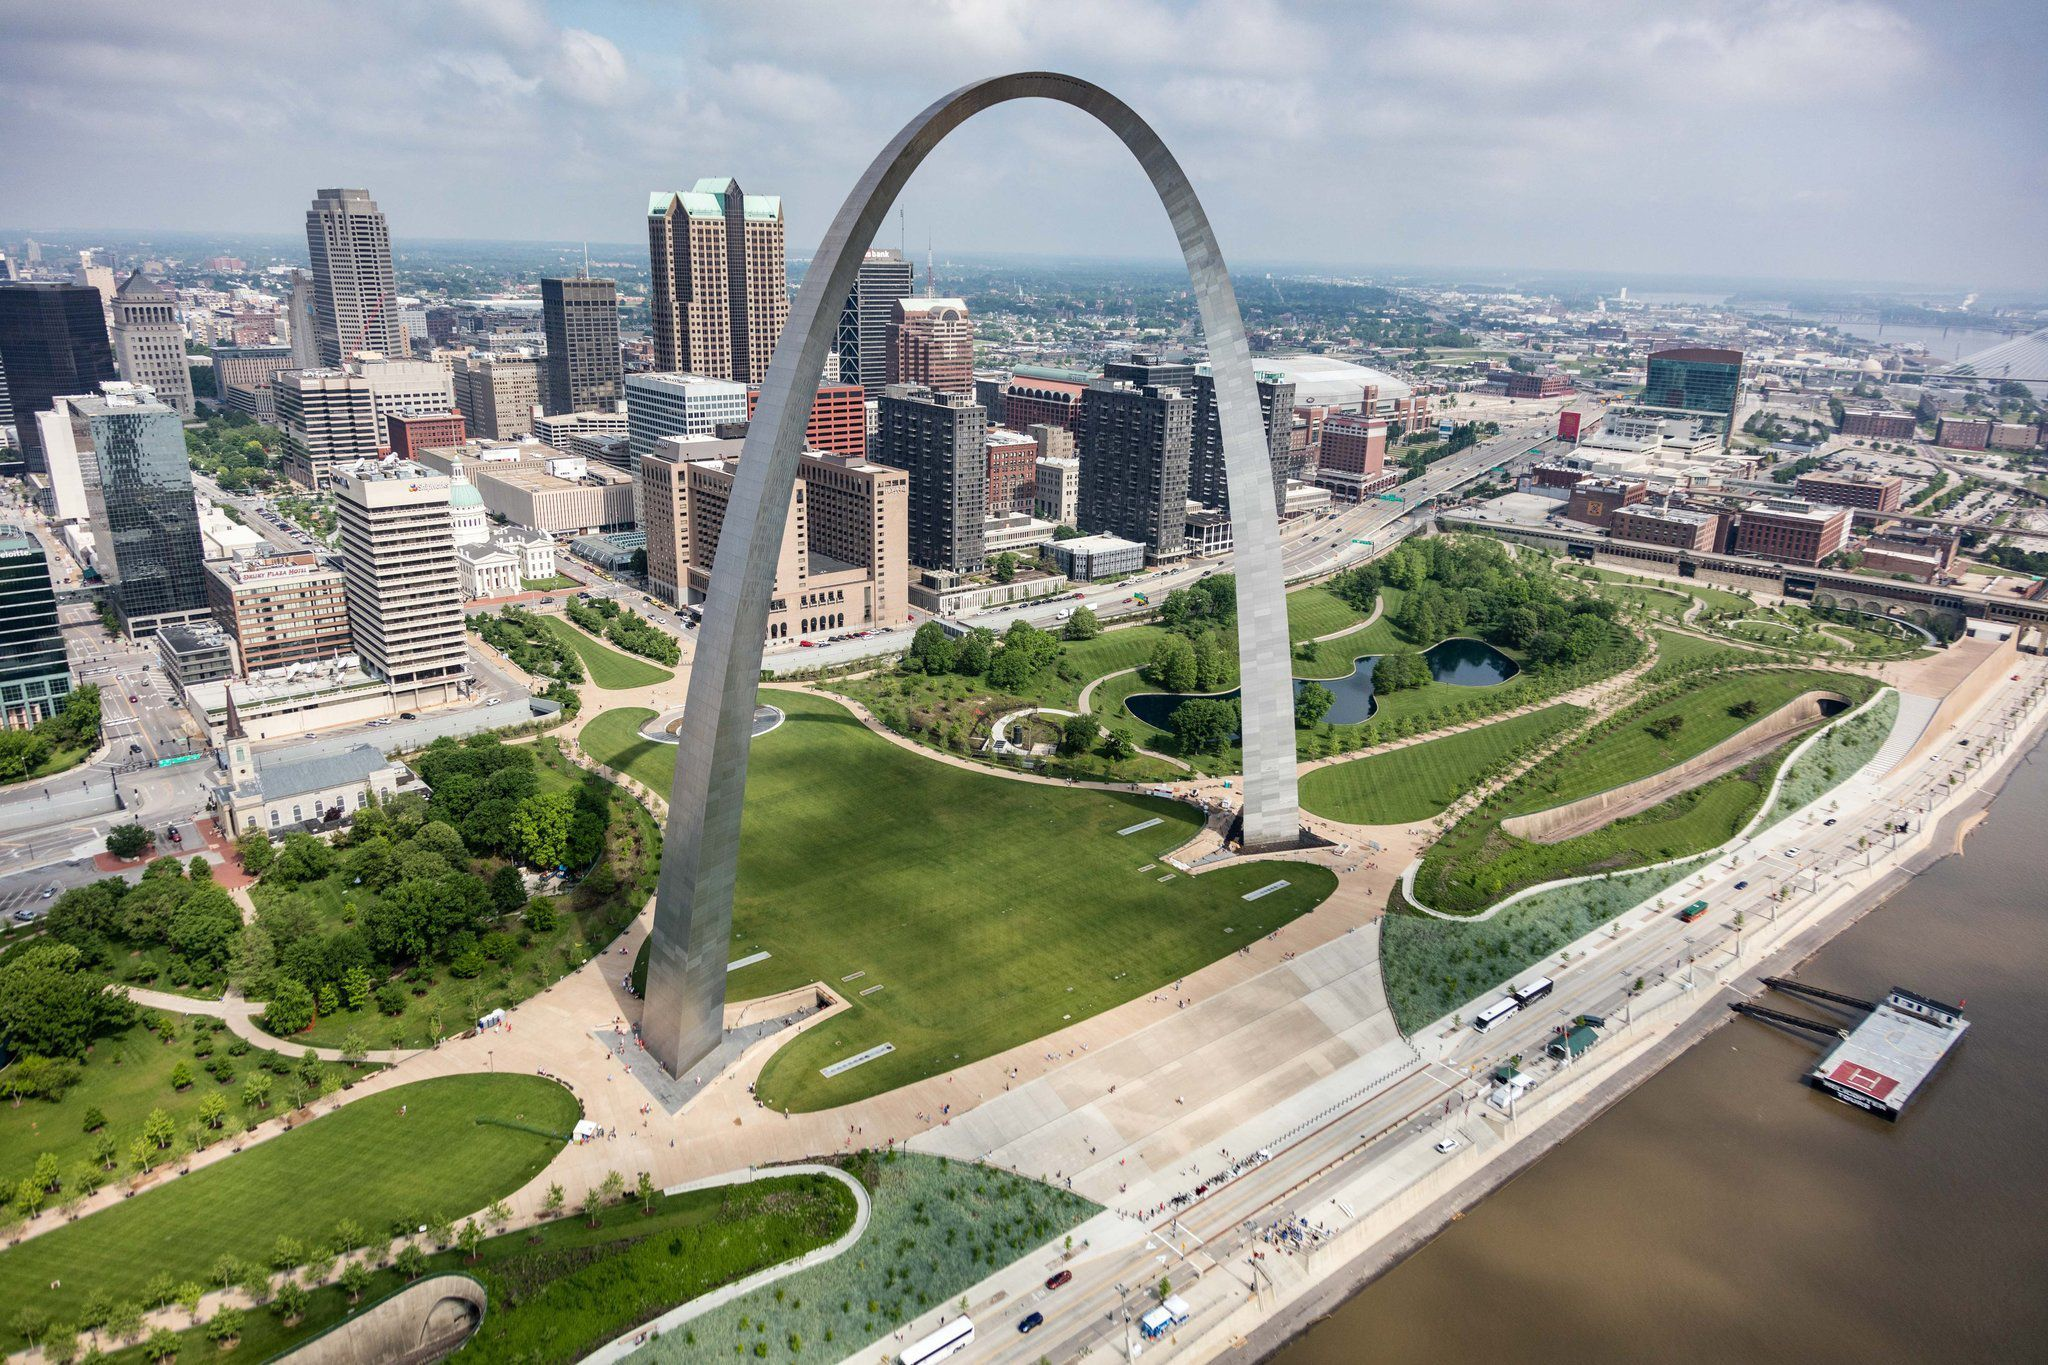How might the scene change in different seasons? In spring, the lush lawns and trees surrounding the Gateway Arch might burst into a vibrant display of blossoms, with cherry blossoms and tulips painting the landscape in vivid hues of pink, yellow, and white. The scene would be alive with the chirping of birds and the fresh scent of blooming flowers.

As summer arrives, the greenery becomes even more vibrant under the bright sun. The area might be bustling with families enjoying picnics, children flying kites, and tourists exploring the grounds. The Mississippi River glistens under the high sun, and boats are more frequent, adding vitality to the scene.

In autumn, the trees would be a riot of color, with leaves turning shades of red, orange, and gold. The air would be crisp, and the scene would evoke a sense of change and reflection. The arch itself would stand strong against a backdrop of falling leaves and a city preparing for the quiet of winter.

Winter paints a serene and subdued picture. The lawns and trees may be dusted with snow, and the arch might be framed by a stark white landscape. The Mississippi freezes in places, creating a tranquil scene of stillness. Few people roam the grounds, giving the area a quiet, introspective feel, with the arch continuing to stand as a beacon in the silent beauty of winter.  How might the view change at different times of the day? At sunrise, the view of the Gateway Arch is bathed in soft, golden light that casts long shadows across the landscape. The early morning dew glistens on the grass, and the city begins to stir awake with the promise of a new day.

By midday, the arch stands tall under the bright blue sky, reflecting the sun's rays off its metallic surface. The city is alive with activity: tourists taking photos, workers bustling about, and boats making their way down the Mississippi River.

During sunset, the sky transforms into a canvas of warm oranges, pinks, and purples, casting the arch and its surroundings in a magical glow. The reflections on the river add to the beauty, creating a serene and picturesque scene as the city transitions from day to night.

At night, the Gateway Arch is illuminated by strategically placed lights, standing out as a shining monument against the dark sky. The city lights twinkle around it, and the quieter sounds of the river at night provide a peaceful backdrop. The arch becomes a beacon of tranquility and reflection, watching over the sleeping city. 